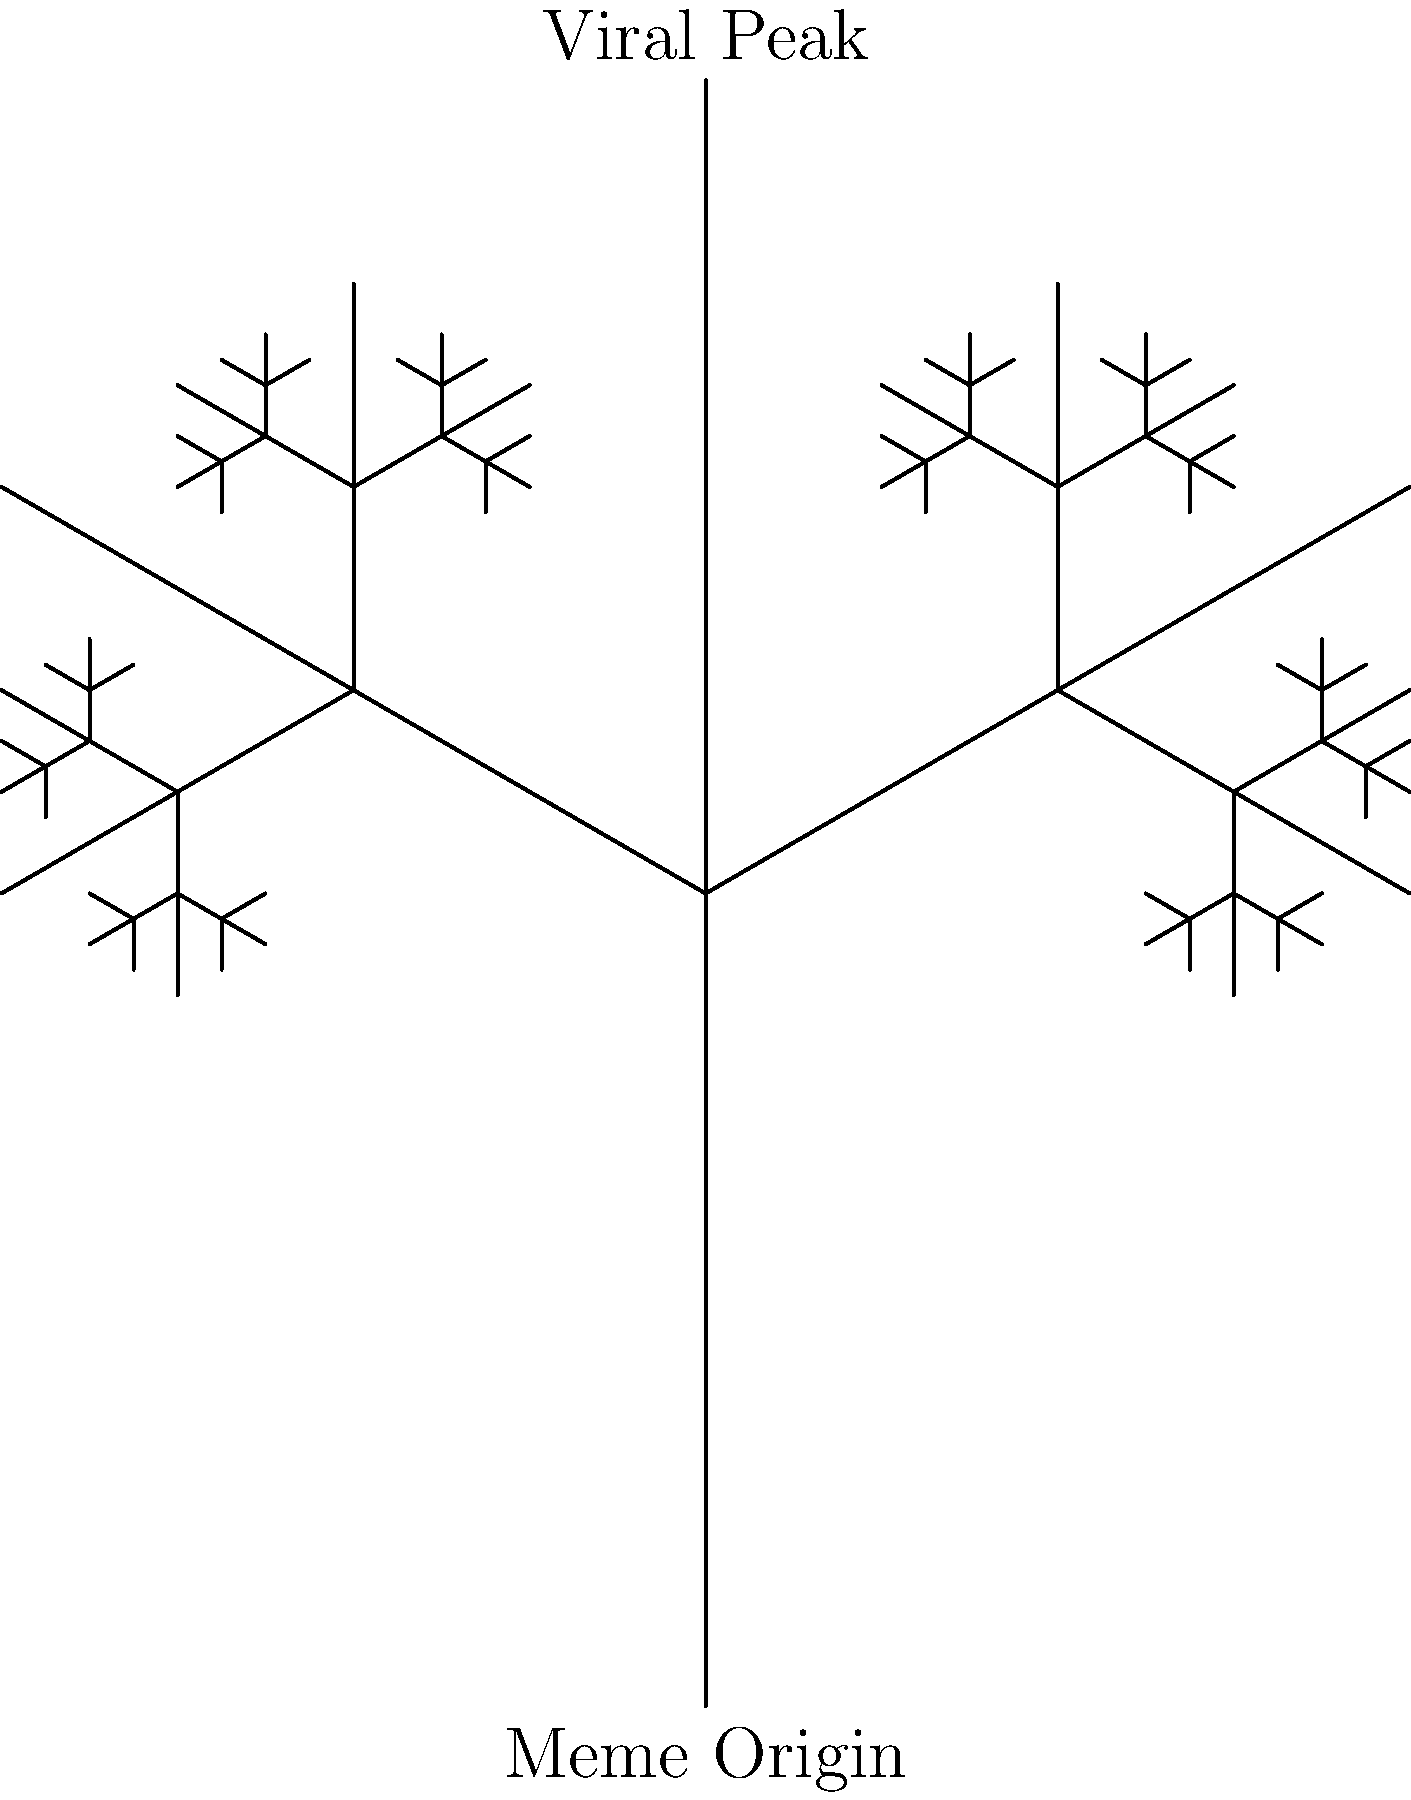In the fractal tree diagram representing internet meme propagation, if each branching point represents a 20% increase in meme spread and the tree has 5 levels, what is the total percentage increase in meme visibility from origin to the furthest endpoints? To solve this problem, we need to follow these steps:

1. Understand the branching structure:
   - The tree has 5 levels
   - Each branching point represents a 20% increase

2. Calculate the cumulative increase for each level:
   Level 1: 100% + 20% = 120%
   Level 2: 120% * 120% = 144%
   Level 3: 144% * 120% = 172.8%
   Level 4: 172.8% * 120% = 207.36%
   Level 5: 207.36% * 120% = 248.832%

3. Calculate the total percentage increase:
   Total increase = Final percentage - Initial percentage
   Total increase = 248.832% - 100% = 148.832%

4. Round to the nearest whole percentage:
   148.832% ≈ 149%

Therefore, the total percentage increase in meme visibility from origin to the furthest endpoints is approximately 149%.
Answer: 149% 